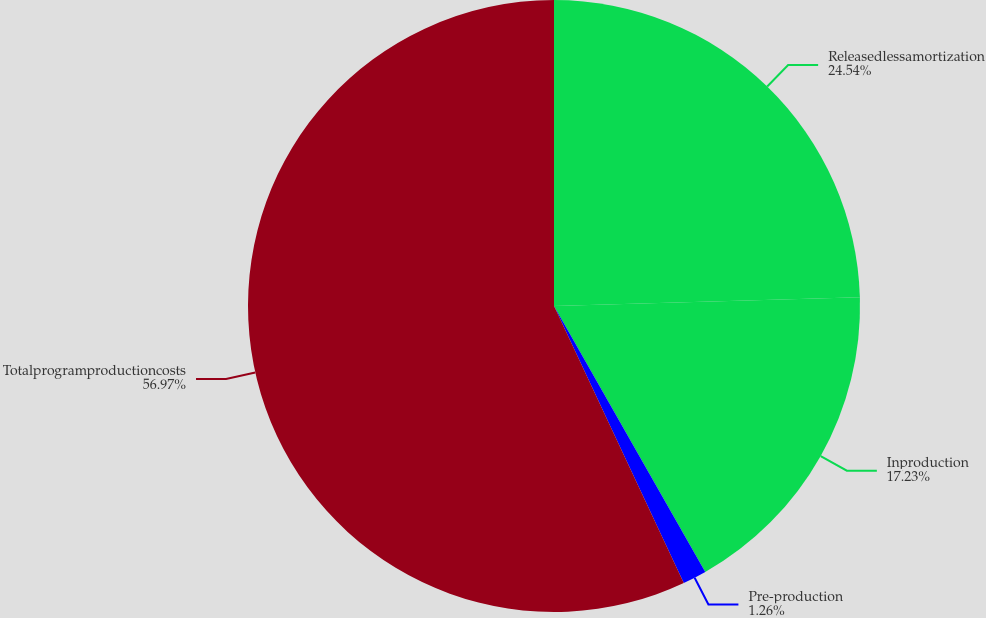Convert chart to OTSL. <chart><loc_0><loc_0><loc_500><loc_500><pie_chart><fcel>Releasedlessamortization<fcel>Inproduction<fcel>Pre-production<fcel>Totalprogramproductioncosts<nl><fcel>24.54%<fcel>17.23%<fcel>1.26%<fcel>56.97%<nl></chart> 